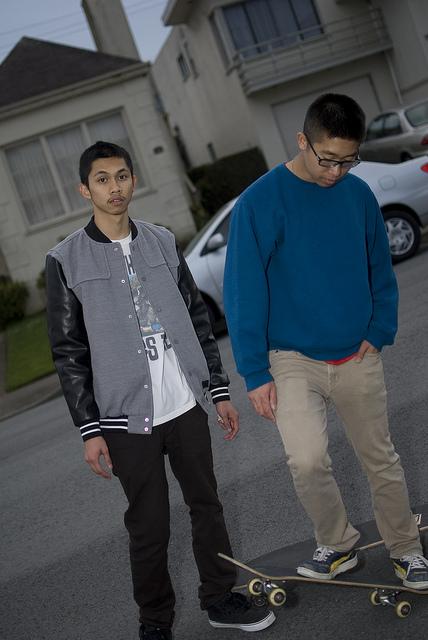What are the men doing?
Answer briefly. Skateboarding. Are they both smiling?
Short answer required. No. What type of coat is the man wearing?
Give a very brief answer. Jacket. Do you think these two men are colleagues?
Keep it brief. No. Do the colors of the jacket and shoes match?
Be succinct. Yes. Is the person on the left wearing sunglasses?
Keep it brief. No. Is that kid on the right wearing a tie-dye shirt?
Quick response, please. No. What is the weather condition?
Give a very brief answer. Cool. Is the boy in blue doing a trick?
Answer briefly. Yes. Do both of these people have hats?
Concise answer only. No. What is the man doing with his left hand?
Quick response, please. In pocket. What is the real hair color of the real man in the photo?
Short answer required. Black. Where are they?
Give a very brief answer. Outside. Is this couple married?
Quick response, please. No. Where is the person skating?
Short answer required. Street. What kind of vehicle is behind the boy?
Answer briefly. Car. What hair style is the man wearing on the left?
Concise answer only. Short. What is he doing?
Short answer required. Skateboarding. How many cars are there?
Keep it brief. 2. Are these men elderly?
Quick response, please. No. How many children are seen?
Write a very short answer. 2. Is there a security man?
Short answer required. No. What is unusual about this skateboard?
Give a very brief answer. Nothing. What is the boy riding?
Write a very short answer. Skateboard. What type of car is in the background?
Write a very short answer. Passenger. Is the man happy?
Short answer required. Yes. What is the boy standing on?
Give a very brief answer. Skateboard. Where is the man's right hand?
Keep it brief. Nothing. What does the man have on his shoulders?
Quick response, please. Nothing. 